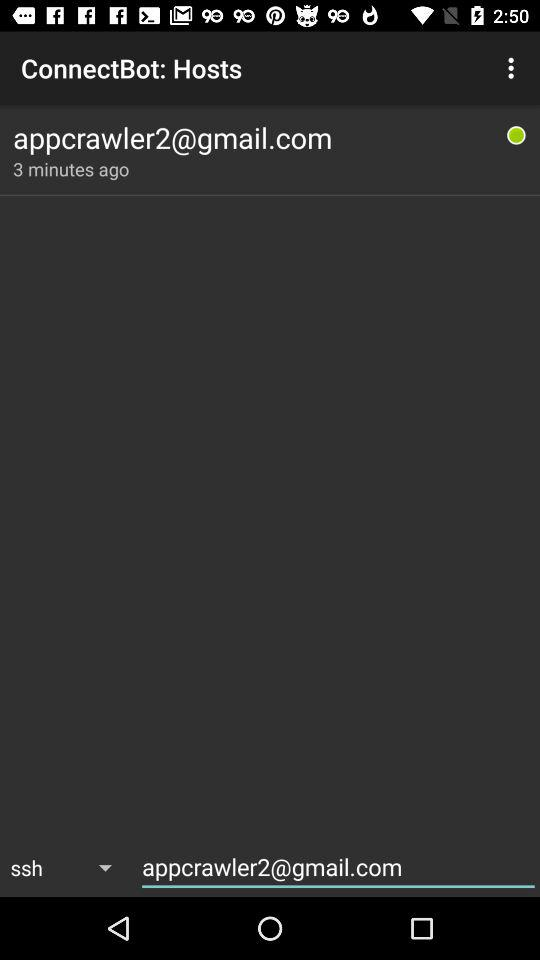When was the user online? The user was online three minutes ago. 